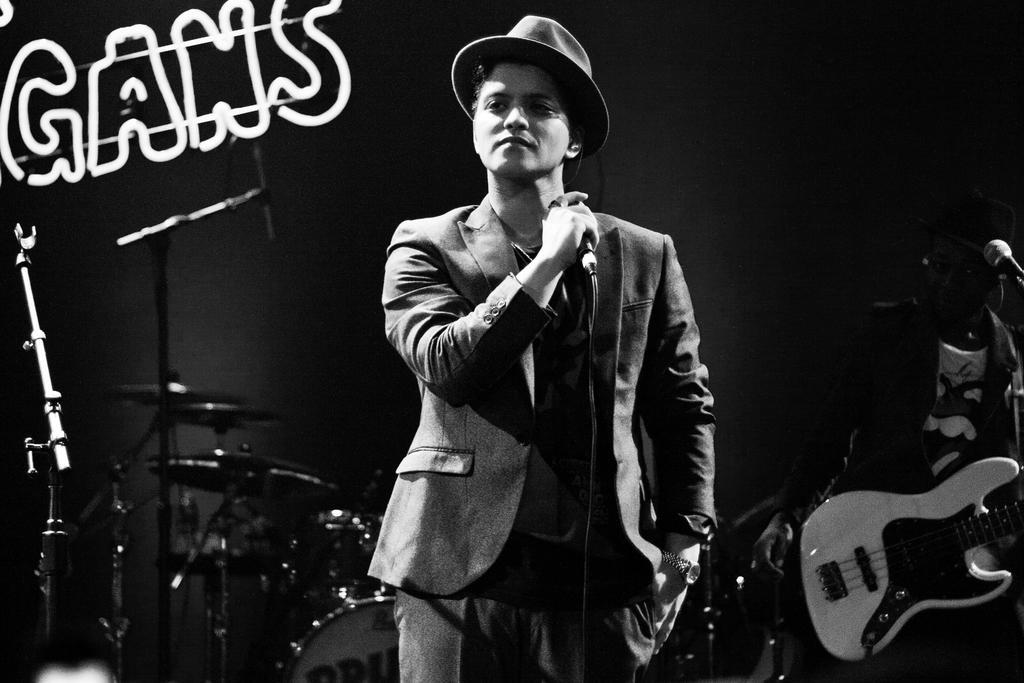Can you describe this image briefly? This is a black and white image. Here is a man standing and holding a mike. I can see another person holding guitar and standing. This is the mike. At background I can see drums. This looks like letter. 